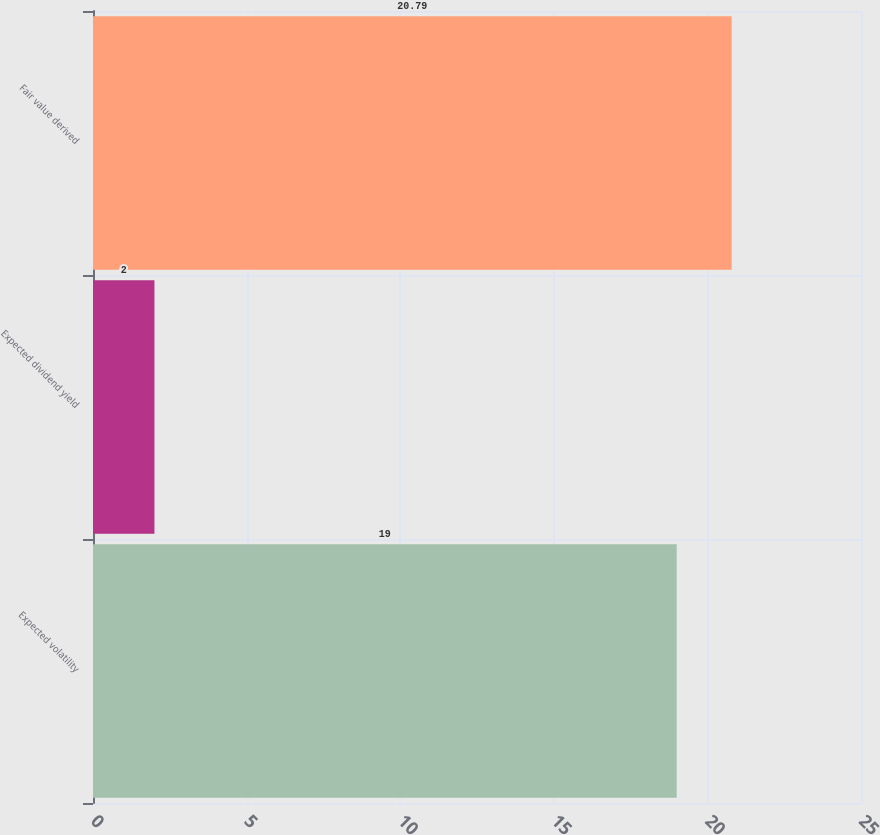Convert chart. <chart><loc_0><loc_0><loc_500><loc_500><bar_chart><fcel>Expected volatility<fcel>Expected dividend yield<fcel>Fair value derived<nl><fcel>19<fcel>2<fcel>20.79<nl></chart> 